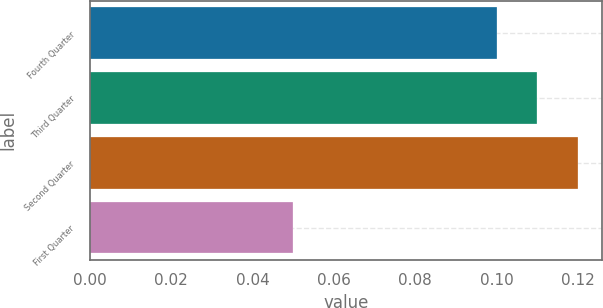Convert chart. <chart><loc_0><loc_0><loc_500><loc_500><bar_chart><fcel>Fourth Quarter<fcel>Third Quarter<fcel>Second Quarter<fcel>First Quarter<nl><fcel>0.1<fcel>0.11<fcel>0.12<fcel>0.05<nl></chart> 